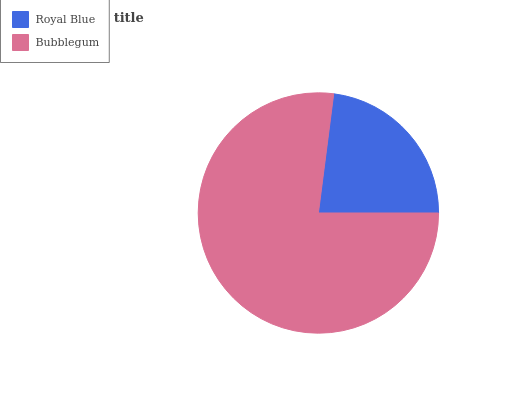Is Royal Blue the minimum?
Answer yes or no. Yes. Is Bubblegum the maximum?
Answer yes or no. Yes. Is Bubblegum the minimum?
Answer yes or no. No. Is Bubblegum greater than Royal Blue?
Answer yes or no. Yes. Is Royal Blue less than Bubblegum?
Answer yes or no. Yes. Is Royal Blue greater than Bubblegum?
Answer yes or no. No. Is Bubblegum less than Royal Blue?
Answer yes or no. No. Is Bubblegum the high median?
Answer yes or no. Yes. Is Royal Blue the low median?
Answer yes or no. Yes. Is Royal Blue the high median?
Answer yes or no. No. Is Bubblegum the low median?
Answer yes or no. No. 